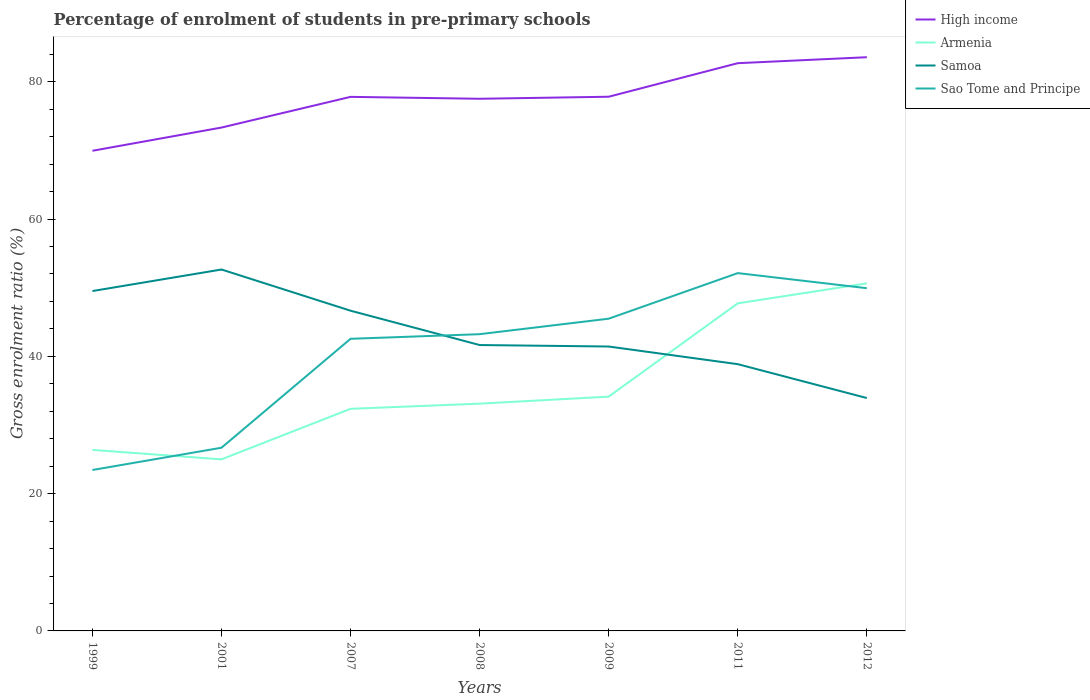Does the line corresponding to High income intersect with the line corresponding to Sao Tome and Principe?
Give a very brief answer. No. Is the number of lines equal to the number of legend labels?
Your answer should be very brief. Yes. Across all years, what is the maximum percentage of students enrolled in pre-primary schools in High income?
Your answer should be compact. 69.94. In which year was the percentage of students enrolled in pre-primary schools in Sao Tome and Principe maximum?
Provide a short and direct response. 1999. What is the total percentage of students enrolled in pre-primary schools in Samoa in the graph?
Provide a succinct answer. 7.79. What is the difference between the highest and the second highest percentage of students enrolled in pre-primary schools in Samoa?
Your answer should be very brief. 18.72. Is the percentage of students enrolled in pre-primary schools in Samoa strictly greater than the percentage of students enrolled in pre-primary schools in Sao Tome and Principe over the years?
Offer a very short reply. No. How many lines are there?
Provide a short and direct response. 4. Are the values on the major ticks of Y-axis written in scientific E-notation?
Make the answer very short. No. Does the graph contain any zero values?
Your answer should be compact. No. Where does the legend appear in the graph?
Your answer should be compact. Top right. What is the title of the graph?
Your answer should be very brief. Percentage of enrolment of students in pre-primary schools. What is the label or title of the X-axis?
Provide a succinct answer. Years. What is the label or title of the Y-axis?
Your answer should be compact. Gross enrolment ratio (%). What is the Gross enrolment ratio (%) in High income in 1999?
Give a very brief answer. 69.94. What is the Gross enrolment ratio (%) in Armenia in 1999?
Your response must be concise. 26.37. What is the Gross enrolment ratio (%) of Samoa in 1999?
Your answer should be compact. 49.51. What is the Gross enrolment ratio (%) of Sao Tome and Principe in 1999?
Offer a terse response. 23.44. What is the Gross enrolment ratio (%) of High income in 2001?
Make the answer very short. 73.33. What is the Gross enrolment ratio (%) in Armenia in 2001?
Provide a succinct answer. 24.99. What is the Gross enrolment ratio (%) in Samoa in 2001?
Give a very brief answer. 52.65. What is the Gross enrolment ratio (%) of Sao Tome and Principe in 2001?
Your answer should be very brief. 26.69. What is the Gross enrolment ratio (%) in High income in 2007?
Offer a very short reply. 77.8. What is the Gross enrolment ratio (%) of Armenia in 2007?
Your answer should be very brief. 32.35. What is the Gross enrolment ratio (%) in Samoa in 2007?
Your answer should be very brief. 46.65. What is the Gross enrolment ratio (%) in Sao Tome and Principe in 2007?
Keep it short and to the point. 42.56. What is the Gross enrolment ratio (%) of High income in 2008?
Ensure brevity in your answer.  77.52. What is the Gross enrolment ratio (%) of Armenia in 2008?
Give a very brief answer. 33.11. What is the Gross enrolment ratio (%) of Samoa in 2008?
Ensure brevity in your answer.  41.65. What is the Gross enrolment ratio (%) of Sao Tome and Principe in 2008?
Your answer should be compact. 43.23. What is the Gross enrolment ratio (%) in High income in 2009?
Keep it short and to the point. 77.82. What is the Gross enrolment ratio (%) of Armenia in 2009?
Keep it short and to the point. 34.13. What is the Gross enrolment ratio (%) of Samoa in 2009?
Your response must be concise. 41.43. What is the Gross enrolment ratio (%) of Sao Tome and Principe in 2009?
Give a very brief answer. 45.48. What is the Gross enrolment ratio (%) of High income in 2011?
Make the answer very short. 82.7. What is the Gross enrolment ratio (%) in Armenia in 2011?
Your response must be concise. 47.72. What is the Gross enrolment ratio (%) of Samoa in 2011?
Your response must be concise. 38.86. What is the Gross enrolment ratio (%) of Sao Tome and Principe in 2011?
Your response must be concise. 52.12. What is the Gross enrolment ratio (%) in High income in 2012?
Your answer should be compact. 83.57. What is the Gross enrolment ratio (%) in Armenia in 2012?
Provide a succinct answer. 50.63. What is the Gross enrolment ratio (%) in Samoa in 2012?
Your response must be concise. 33.92. What is the Gross enrolment ratio (%) in Sao Tome and Principe in 2012?
Your answer should be very brief. 49.93. Across all years, what is the maximum Gross enrolment ratio (%) of High income?
Make the answer very short. 83.57. Across all years, what is the maximum Gross enrolment ratio (%) of Armenia?
Keep it short and to the point. 50.63. Across all years, what is the maximum Gross enrolment ratio (%) in Samoa?
Provide a short and direct response. 52.65. Across all years, what is the maximum Gross enrolment ratio (%) in Sao Tome and Principe?
Give a very brief answer. 52.12. Across all years, what is the minimum Gross enrolment ratio (%) of High income?
Ensure brevity in your answer.  69.94. Across all years, what is the minimum Gross enrolment ratio (%) in Armenia?
Your response must be concise. 24.99. Across all years, what is the minimum Gross enrolment ratio (%) of Samoa?
Keep it short and to the point. 33.92. Across all years, what is the minimum Gross enrolment ratio (%) in Sao Tome and Principe?
Make the answer very short. 23.44. What is the total Gross enrolment ratio (%) of High income in the graph?
Provide a short and direct response. 542.68. What is the total Gross enrolment ratio (%) of Armenia in the graph?
Provide a succinct answer. 249.3. What is the total Gross enrolment ratio (%) of Samoa in the graph?
Offer a terse response. 304.67. What is the total Gross enrolment ratio (%) of Sao Tome and Principe in the graph?
Your answer should be very brief. 283.45. What is the difference between the Gross enrolment ratio (%) of High income in 1999 and that in 2001?
Offer a terse response. -3.38. What is the difference between the Gross enrolment ratio (%) in Armenia in 1999 and that in 2001?
Your answer should be very brief. 1.37. What is the difference between the Gross enrolment ratio (%) of Samoa in 1999 and that in 2001?
Make the answer very short. -3.14. What is the difference between the Gross enrolment ratio (%) of Sao Tome and Principe in 1999 and that in 2001?
Offer a terse response. -3.25. What is the difference between the Gross enrolment ratio (%) in High income in 1999 and that in 2007?
Offer a very short reply. -7.85. What is the difference between the Gross enrolment ratio (%) in Armenia in 1999 and that in 2007?
Keep it short and to the point. -5.99. What is the difference between the Gross enrolment ratio (%) in Samoa in 1999 and that in 2007?
Keep it short and to the point. 2.86. What is the difference between the Gross enrolment ratio (%) of Sao Tome and Principe in 1999 and that in 2007?
Keep it short and to the point. -19.11. What is the difference between the Gross enrolment ratio (%) of High income in 1999 and that in 2008?
Provide a short and direct response. -7.58. What is the difference between the Gross enrolment ratio (%) of Armenia in 1999 and that in 2008?
Offer a very short reply. -6.74. What is the difference between the Gross enrolment ratio (%) in Samoa in 1999 and that in 2008?
Provide a short and direct response. 7.86. What is the difference between the Gross enrolment ratio (%) in Sao Tome and Principe in 1999 and that in 2008?
Provide a succinct answer. -19.78. What is the difference between the Gross enrolment ratio (%) in High income in 1999 and that in 2009?
Make the answer very short. -7.87. What is the difference between the Gross enrolment ratio (%) of Armenia in 1999 and that in 2009?
Offer a very short reply. -7.76. What is the difference between the Gross enrolment ratio (%) in Samoa in 1999 and that in 2009?
Provide a succinct answer. 8.08. What is the difference between the Gross enrolment ratio (%) in Sao Tome and Principe in 1999 and that in 2009?
Provide a succinct answer. -22.04. What is the difference between the Gross enrolment ratio (%) in High income in 1999 and that in 2011?
Make the answer very short. -12.76. What is the difference between the Gross enrolment ratio (%) of Armenia in 1999 and that in 2011?
Your answer should be very brief. -21.35. What is the difference between the Gross enrolment ratio (%) in Samoa in 1999 and that in 2011?
Your answer should be compact. 10.65. What is the difference between the Gross enrolment ratio (%) in Sao Tome and Principe in 1999 and that in 2011?
Your answer should be compact. -28.68. What is the difference between the Gross enrolment ratio (%) in High income in 1999 and that in 2012?
Offer a terse response. -13.63. What is the difference between the Gross enrolment ratio (%) in Armenia in 1999 and that in 2012?
Ensure brevity in your answer.  -24.26. What is the difference between the Gross enrolment ratio (%) in Samoa in 1999 and that in 2012?
Provide a short and direct response. 15.59. What is the difference between the Gross enrolment ratio (%) of Sao Tome and Principe in 1999 and that in 2012?
Make the answer very short. -26.48. What is the difference between the Gross enrolment ratio (%) of High income in 2001 and that in 2007?
Give a very brief answer. -4.47. What is the difference between the Gross enrolment ratio (%) of Armenia in 2001 and that in 2007?
Keep it short and to the point. -7.36. What is the difference between the Gross enrolment ratio (%) in Samoa in 2001 and that in 2007?
Offer a terse response. 6. What is the difference between the Gross enrolment ratio (%) in Sao Tome and Principe in 2001 and that in 2007?
Your answer should be compact. -15.87. What is the difference between the Gross enrolment ratio (%) of High income in 2001 and that in 2008?
Provide a succinct answer. -4.19. What is the difference between the Gross enrolment ratio (%) in Armenia in 2001 and that in 2008?
Ensure brevity in your answer.  -8.12. What is the difference between the Gross enrolment ratio (%) of Samoa in 2001 and that in 2008?
Ensure brevity in your answer.  11. What is the difference between the Gross enrolment ratio (%) of Sao Tome and Principe in 2001 and that in 2008?
Provide a succinct answer. -16.54. What is the difference between the Gross enrolment ratio (%) of High income in 2001 and that in 2009?
Make the answer very short. -4.49. What is the difference between the Gross enrolment ratio (%) of Armenia in 2001 and that in 2009?
Offer a very short reply. -9.14. What is the difference between the Gross enrolment ratio (%) in Samoa in 2001 and that in 2009?
Ensure brevity in your answer.  11.22. What is the difference between the Gross enrolment ratio (%) in Sao Tome and Principe in 2001 and that in 2009?
Give a very brief answer. -18.79. What is the difference between the Gross enrolment ratio (%) of High income in 2001 and that in 2011?
Your response must be concise. -9.38. What is the difference between the Gross enrolment ratio (%) in Armenia in 2001 and that in 2011?
Your response must be concise. -22.73. What is the difference between the Gross enrolment ratio (%) of Samoa in 2001 and that in 2011?
Make the answer very short. 13.79. What is the difference between the Gross enrolment ratio (%) in Sao Tome and Principe in 2001 and that in 2011?
Your response must be concise. -25.44. What is the difference between the Gross enrolment ratio (%) in High income in 2001 and that in 2012?
Offer a very short reply. -10.25. What is the difference between the Gross enrolment ratio (%) of Armenia in 2001 and that in 2012?
Give a very brief answer. -25.64. What is the difference between the Gross enrolment ratio (%) in Samoa in 2001 and that in 2012?
Give a very brief answer. 18.72. What is the difference between the Gross enrolment ratio (%) of Sao Tome and Principe in 2001 and that in 2012?
Provide a short and direct response. -23.24. What is the difference between the Gross enrolment ratio (%) in High income in 2007 and that in 2008?
Give a very brief answer. 0.28. What is the difference between the Gross enrolment ratio (%) of Armenia in 2007 and that in 2008?
Make the answer very short. -0.75. What is the difference between the Gross enrolment ratio (%) in Samoa in 2007 and that in 2008?
Keep it short and to the point. 5. What is the difference between the Gross enrolment ratio (%) in Sao Tome and Principe in 2007 and that in 2008?
Give a very brief answer. -0.67. What is the difference between the Gross enrolment ratio (%) of High income in 2007 and that in 2009?
Ensure brevity in your answer.  -0.02. What is the difference between the Gross enrolment ratio (%) of Armenia in 2007 and that in 2009?
Offer a very short reply. -1.77. What is the difference between the Gross enrolment ratio (%) in Samoa in 2007 and that in 2009?
Your answer should be very brief. 5.22. What is the difference between the Gross enrolment ratio (%) of Sao Tome and Principe in 2007 and that in 2009?
Provide a succinct answer. -2.93. What is the difference between the Gross enrolment ratio (%) of High income in 2007 and that in 2011?
Give a very brief answer. -4.91. What is the difference between the Gross enrolment ratio (%) in Armenia in 2007 and that in 2011?
Make the answer very short. -15.37. What is the difference between the Gross enrolment ratio (%) in Samoa in 2007 and that in 2011?
Give a very brief answer. 7.79. What is the difference between the Gross enrolment ratio (%) in Sao Tome and Principe in 2007 and that in 2011?
Provide a succinct answer. -9.57. What is the difference between the Gross enrolment ratio (%) in High income in 2007 and that in 2012?
Give a very brief answer. -5.77. What is the difference between the Gross enrolment ratio (%) of Armenia in 2007 and that in 2012?
Your answer should be very brief. -18.28. What is the difference between the Gross enrolment ratio (%) of Samoa in 2007 and that in 2012?
Ensure brevity in your answer.  12.72. What is the difference between the Gross enrolment ratio (%) of Sao Tome and Principe in 2007 and that in 2012?
Ensure brevity in your answer.  -7.37. What is the difference between the Gross enrolment ratio (%) in High income in 2008 and that in 2009?
Offer a terse response. -0.3. What is the difference between the Gross enrolment ratio (%) of Armenia in 2008 and that in 2009?
Your answer should be compact. -1.02. What is the difference between the Gross enrolment ratio (%) in Samoa in 2008 and that in 2009?
Provide a succinct answer. 0.22. What is the difference between the Gross enrolment ratio (%) of Sao Tome and Principe in 2008 and that in 2009?
Make the answer very short. -2.26. What is the difference between the Gross enrolment ratio (%) of High income in 2008 and that in 2011?
Give a very brief answer. -5.18. What is the difference between the Gross enrolment ratio (%) in Armenia in 2008 and that in 2011?
Your response must be concise. -14.61. What is the difference between the Gross enrolment ratio (%) of Samoa in 2008 and that in 2011?
Give a very brief answer. 2.79. What is the difference between the Gross enrolment ratio (%) in Sao Tome and Principe in 2008 and that in 2011?
Ensure brevity in your answer.  -8.9. What is the difference between the Gross enrolment ratio (%) in High income in 2008 and that in 2012?
Provide a succinct answer. -6.05. What is the difference between the Gross enrolment ratio (%) of Armenia in 2008 and that in 2012?
Offer a very short reply. -17.52. What is the difference between the Gross enrolment ratio (%) in Samoa in 2008 and that in 2012?
Provide a short and direct response. 7.72. What is the difference between the Gross enrolment ratio (%) of Sao Tome and Principe in 2008 and that in 2012?
Provide a short and direct response. -6.7. What is the difference between the Gross enrolment ratio (%) in High income in 2009 and that in 2011?
Offer a terse response. -4.89. What is the difference between the Gross enrolment ratio (%) in Armenia in 2009 and that in 2011?
Your answer should be compact. -13.59. What is the difference between the Gross enrolment ratio (%) in Samoa in 2009 and that in 2011?
Ensure brevity in your answer.  2.57. What is the difference between the Gross enrolment ratio (%) in Sao Tome and Principe in 2009 and that in 2011?
Provide a short and direct response. -6.64. What is the difference between the Gross enrolment ratio (%) of High income in 2009 and that in 2012?
Offer a very short reply. -5.76. What is the difference between the Gross enrolment ratio (%) of Armenia in 2009 and that in 2012?
Provide a short and direct response. -16.5. What is the difference between the Gross enrolment ratio (%) in Samoa in 2009 and that in 2012?
Provide a short and direct response. 7.5. What is the difference between the Gross enrolment ratio (%) of Sao Tome and Principe in 2009 and that in 2012?
Keep it short and to the point. -4.44. What is the difference between the Gross enrolment ratio (%) of High income in 2011 and that in 2012?
Keep it short and to the point. -0.87. What is the difference between the Gross enrolment ratio (%) in Armenia in 2011 and that in 2012?
Keep it short and to the point. -2.91. What is the difference between the Gross enrolment ratio (%) in Samoa in 2011 and that in 2012?
Give a very brief answer. 4.93. What is the difference between the Gross enrolment ratio (%) of Sao Tome and Principe in 2011 and that in 2012?
Give a very brief answer. 2.2. What is the difference between the Gross enrolment ratio (%) in High income in 1999 and the Gross enrolment ratio (%) in Armenia in 2001?
Provide a short and direct response. 44.95. What is the difference between the Gross enrolment ratio (%) of High income in 1999 and the Gross enrolment ratio (%) of Samoa in 2001?
Offer a terse response. 17.3. What is the difference between the Gross enrolment ratio (%) of High income in 1999 and the Gross enrolment ratio (%) of Sao Tome and Principe in 2001?
Offer a very short reply. 43.26. What is the difference between the Gross enrolment ratio (%) of Armenia in 1999 and the Gross enrolment ratio (%) of Samoa in 2001?
Your answer should be compact. -26.28. What is the difference between the Gross enrolment ratio (%) in Armenia in 1999 and the Gross enrolment ratio (%) in Sao Tome and Principe in 2001?
Your answer should be very brief. -0.32. What is the difference between the Gross enrolment ratio (%) of Samoa in 1999 and the Gross enrolment ratio (%) of Sao Tome and Principe in 2001?
Your response must be concise. 22.82. What is the difference between the Gross enrolment ratio (%) of High income in 1999 and the Gross enrolment ratio (%) of Armenia in 2007?
Offer a terse response. 37.59. What is the difference between the Gross enrolment ratio (%) of High income in 1999 and the Gross enrolment ratio (%) of Samoa in 2007?
Your answer should be compact. 23.3. What is the difference between the Gross enrolment ratio (%) in High income in 1999 and the Gross enrolment ratio (%) in Sao Tome and Principe in 2007?
Make the answer very short. 27.39. What is the difference between the Gross enrolment ratio (%) of Armenia in 1999 and the Gross enrolment ratio (%) of Samoa in 2007?
Provide a short and direct response. -20.28. What is the difference between the Gross enrolment ratio (%) of Armenia in 1999 and the Gross enrolment ratio (%) of Sao Tome and Principe in 2007?
Offer a terse response. -16.19. What is the difference between the Gross enrolment ratio (%) of Samoa in 1999 and the Gross enrolment ratio (%) of Sao Tome and Principe in 2007?
Offer a terse response. 6.96. What is the difference between the Gross enrolment ratio (%) of High income in 1999 and the Gross enrolment ratio (%) of Armenia in 2008?
Provide a short and direct response. 36.84. What is the difference between the Gross enrolment ratio (%) of High income in 1999 and the Gross enrolment ratio (%) of Samoa in 2008?
Make the answer very short. 28.3. What is the difference between the Gross enrolment ratio (%) in High income in 1999 and the Gross enrolment ratio (%) in Sao Tome and Principe in 2008?
Keep it short and to the point. 26.72. What is the difference between the Gross enrolment ratio (%) in Armenia in 1999 and the Gross enrolment ratio (%) in Samoa in 2008?
Offer a very short reply. -15.28. What is the difference between the Gross enrolment ratio (%) of Armenia in 1999 and the Gross enrolment ratio (%) of Sao Tome and Principe in 2008?
Offer a very short reply. -16.86. What is the difference between the Gross enrolment ratio (%) in Samoa in 1999 and the Gross enrolment ratio (%) in Sao Tome and Principe in 2008?
Give a very brief answer. 6.28. What is the difference between the Gross enrolment ratio (%) of High income in 1999 and the Gross enrolment ratio (%) of Armenia in 2009?
Make the answer very short. 35.82. What is the difference between the Gross enrolment ratio (%) of High income in 1999 and the Gross enrolment ratio (%) of Samoa in 2009?
Offer a terse response. 28.51. What is the difference between the Gross enrolment ratio (%) of High income in 1999 and the Gross enrolment ratio (%) of Sao Tome and Principe in 2009?
Provide a short and direct response. 24.46. What is the difference between the Gross enrolment ratio (%) in Armenia in 1999 and the Gross enrolment ratio (%) in Samoa in 2009?
Keep it short and to the point. -15.06. What is the difference between the Gross enrolment ratio (%) of Armenia in 1999 and the Gross enrolment ratio (%) of Sao Tome and Principe in 2009?
Your response must be concise. -19.12. What is the difference between the Gross enrolment ratio (%) of Samoa in 1999 and the Gross enrolment ratio (%) of Sao Tome and Principe in 2009?
Offer a very short reply. 4.03. What is the difference between the Gross enrolment ratio (%) in High income in 1999 and the Gross enrolment ratio (%) in Armenia in 2011?
Give a very brief answer. 22.22. What is the difference between the Gross enrolment ratio (%) of High income in 1999 and the Gross enrolment ratio (%) of Samoa in 2011?
Your answer should be very brief. 31.08. What is the difference between the Gross enrolment ratio (%) in High income in 1999 and the Gross enrolment ratio (%) in Sao Tome and Principe in 2011?
Offer a very short reply. 17.82. What is the difference between the Gross enrolment ratio (%) of Armenia in 1999 and the Gross enrolment ratio (%) of Samoa in 2011?
Your answer should be compact. -12.49. What is the difference between the Gross enrolment ratio (%) of Armenia in 1999 and the Gross enrolment ratio (%) of Sao Tome and Principe in 2011?
Offer a very short reply. -25.76. What is the difference between the Gross enrolment ratio (%) of Samoa in 1999 and the Gross enrolment ratio (%) of Sao Tome and Principe in 2011?
Offer a terse response. -2.61. What is the difference between the Gross enrolment ratio (%) of High income in 1999 and the Gross enrolment ratio (%) of Armenia in 2012?
Your answer should be very brief. 19.31. What is the difference between the Gross enrolment ratio (%) of High income in 1999 and the Gross enrolment ratio (%) of Samoa in 2012?
Your answer should be compact. 36.02. What is the difference between the Gross enrolment ratio (%) of High income in 1999 and the Gross enrolment ratio (%) of Sao Tome and Principe in 2012?
Your response must be concise. 20.02. What is the difference between the Gross enrolment ratio (%) of Armenia in 1999 and the Gross enrolment ratio (%) of Samoa in 2012?
Your answer should be compact. -7.56. What is the difference between the Gross enrolment ratio (%) in Armenia in 1999 and the Gross enrolment ratio (%) in Sao Tome and Principe in 2012?
Your answer should be compact. -23.56. What is the difference between the Gross enrolment ratio (%) of Samoa in 1999 and the Gross enrolment ratio (%) of Sao Tome and Principe in 2012?
Your answer should be very brief. -0.42. What is the difference between the Gross enrolment ratio (%) of High income in 2001 and the Gross enrolment ratio (%) of Armenia in 2007?
Your response must be concise. 40.97. What is the difference between the Gross enrolment ratio (%) in High income in 2001 and the Gross enrolment ratio (%) in Samoa in 2007?
Ensure brevity in your answer.  26.68. What is the difference between the Gross enrolment ratio (%) in High income in 2001 and the Gross enrolment ratio (%) in Sao Tome and Principe in 2007?
Offer a very short reply. 30.77. What is the difference between the Gross enrolment ratio (%) of Armenia in 2001 and the Gross enrolment ratio (%) of Samoa in 2007?
Offer a very short reply. -21.66. What is the difference between the Gross enrolment ratio (%) in Armenia in 2001 and the Gross enrolment ratio (%) in Sao Tome and Principe in 2007?
Offer a terse response. -17.56. What is the difference between the Gross enrolment ratio (%) in Samoa in 2001 and the Gross enrolment ratio (%) in Sao Tome and Principe in 2007?
Make the answer very short. 10.09. What is the difference between the Gross enrolment ratio (%) in High income in 2001 and the Gross enrolment ratio (%) in Armenia in 2008?
Your response must be concise. 40.22. What is the difference between the Gross enrolment ratio (%) of High income in 2001 and the Gross enrolment ratio (%) of Samoa in 2008?
Your answer should be very brief. 31.68. What is the difference between the Gross enrolment ratio (%) of High income in 2001 and the Gross enrolment ratio (%) of Sao Tome and Principe in 2008?
Your answer should be compact. 30.1. What is the difference between the Gross enrolment ratio (%) of Armenia in 2001 and the Gross enrolment ratio (%) of Samoa in 2008?
Provide a short and direct response. -16.65. What is the difference between the Gross enrolment ratio (%) in Armenia in 2001 and the Gross enrolment ratio (%) in Sao Tome and Principe in 2008?
Ensure brevity in your answer.  -18.23. What is the difference between the Gross enrolment ratio (%) in Samoa in 2001 and the Gross enrolment ratio (%) in Sao Tome and Principe in 2008?
Provide a succinct answer. 9.42. What is the difference between the Gross enrolment ratio (%) of High income in 2001 and the Gross enrolment ratio (%) of Armenia in 2009?
Offer a very short reply. 39.2. What is the difference between the Gross enrolment ratio (%) in High income in 2001 and the Gross enrolment ratio (%) in Samoa in 2009?
Your answer should be very brief. 31.9. What is the difference between the Gross enrolment ratio (%) in High income in 2001 and the Gross enrolment ratio (%) in Sao Tome and Principe in 2009?
Provide a succinct answer. 27.84. What is the difference between the Gross enrolment ratio (%) of Armenia in 2001 and the Gross enrolment ratio (%) of Samoa in 2009?
Offer a terse response. -16.44. What is the difference between the Gross enrolment ratio (%) of Armenia in 2001 and the Gross enrolment ratio (%) of Sao Tome and Principe in 2009?
Keep it short and to the point. -20.49. What is the difference between the Gross enrolment ratio (%) in Samoa in 2001 and the Gross enrolment ratio (%) in Sao Tome and Principe in 2009?
Provide a short and direct response. 7.17. What is the difference between the Gross enrolment ratio (%) in High income in 2001 and the Gross enrolment ratio (%) in Armenia in 2011?
Make the answer very short. 25.61. What is the difference between the Gross enrolment ratio (%) in High income in 2001 and the Gross enrolment ratio (%) in Samoa in 2011?
Your answer should be compact. 34.47. What is the difference between the Gross enrolment ratio (%) of High income in 2001 and the Gross enrolment ratio (%) of Sao Tome and Principe in 2011?
Give a very brief answer. 21.2. What is the difference between the Gross enrolment ratio (%) in Armenia in 2001 and the Gross enrolment ratio (%) in Samoa in 2011?
Keep it short and to the point. -13.87. What is the difference between the Gross enrolment ratio (%) of Armenia in 2001 and the Gross enrolment ratio (%) of Sao Tome and Principe in 2011?
Your response must be concise. -27.13. What is the difference between the Gross enrolment ratio (%) of Samoa in 2001 and the Gross enrolment ratio (%) of Sao Tome and Principe in 2011?
Ensure brevity in your answer.  0.52. What is the difference between the Gross enrolment ratio (%) of High income in 2001 and the Gross enrolment ratio (%) of Armenia in 2012?
Your answer should be very brief. 22.7. What is the difference between the Gross enrolment ratio (%) in High income in 2001 and the Gross enrolment ratio (%) in Samoa in 2012?
Your answer should be compact. 39.4. What is the difference between the Gross enrolment ratio (%) in High income in 2001 and the Gross enrolment ratio (%) in Sao Tome and Principe in 2012?
Keep it short and to the point. 23.4. What is the difference between the Gross enrolment ratio (%) in Armenia in 2001 and the Gross enrolment ratio (%) in Samoa in 2012?
Your answer should be compact. -8.93. What is the difference between the Gross enrolment ratio (%) in Armenia in 2001 and the Gross enrolment ratio (%) in Sao Tome and Principe in 2012?
Ensure brevity in your answer.  -24.93. What is the difference between the Gross enrolment ratio (%) in Samoa in 2001 and the Gross enrolment ratio (%) in Sao Tome and Principe in 2012?
Keep it short and to the point. 2.72. What is the difference between the Gross enrolment ratio (%) in High income in 2007 and the Gross enrolment ratio (%) in Armenia in 2008?
Offer a very short reply. 44.69. What is the difference between the Gross enrolment ratio (%) in High income in 2007 and the Gross enrolment ratio (%) in Samoa in 2008?
Give a very brief answer. 36.15. What is the difference between the Gross enrolment ratio (%) of High income in 2007 and the Gross enrolment ratio (%) of Sao Tome and Principe in 2008?
Keep it short and to the point. 34.57. What is the difference between the Gross enrolment ratio (%) of Armenia in 2007 and the Gross enrolment ratio (%) of Samoa in 2008?
Offer a terse response. -9.29. What is the difference between the Gross enrolment ratio (%) in Armenia in 2007 and the Gross enrolment ratio (%) in Sao Tome and Principe in 2008?
Your answer should be compact. -10.87. What is the difference between the Gross enrolment ratio (%) in Samoa in 2007 and the Gross enrolment ratio (%) in Sao Tome and Principe in 2008?
Give a very brief answer. 3.42. What is the difference between the Gross enrolment ratio (%) of High income in 2007 and the Gross enrolment ratio (%) of Armenia in 2009?
Make the answer very short. 43.67. What is the difference between the Gross enrolment ratio (%) of High income in 2007 and the Gross enrolment ratio (%) of Samoa in 2009?
Your answer should be compact. 36.37. What is the difference between the Gross enrolment ratio (%) in High income in 2007 and the Gross enrolment ratio (%) in Sao Tome and Principe in 2009?
Your answer should be compact. 32.32. What is the difference between the Gross enrolment ratio (%) in Armenia in 2007 and the Gross enrolment ratio (%) in Samoa in 2009?
Make the answer very short. -9.08. What is the difference between the Gross enrolment ratio (%) in Armenia in 2007 and the Gross enrolment ratio (%) in Sao Tome and Principe in 2009?
Your answer should be very brief. -13.13. What is the difference between the Gross enrolment ratio (%) of Samoa in 2007 and the Gross enrolment ratio (%) of Sao Tome and Principe in 2009?
Your answer should be compact. 1.17. What is the difference between the Gross enrolment ratio (%) in High income in 2007 and the Gross enrolment ratio (%) in Armenia in 2011?
Make the answer very short. 30.08. What is the difference between the Gross enrolment ratio (%) of High income in 2007 and the Gross enrolment ratio (%) of Samoa in 2011?
Offer a terse response. 38.94. What is the difference between the Gross enrolment ratio (%) in High income in 2007 and the Gross enrolment ratio (%) in Sao Tome and Principe in 2011?
Offer a very short reply. 25.67. What is the difference between the Gross enrolment ratio (%) of Armenia in 2007 and the Gross enrolment ratio (%) of Samoa in 2011?
Offer a very short reply. -6.5. What is the difference between the Gross enrolment ratio (%) in Armenia in 2007 and the Gross enrolment ratio (%) in Sao Tome and Principe in 2011?
Provide a short and direct response. -19.77. What is the difference between the Gross enrolment ratio (%) in Samoa in 2007 and the Gross enrolment ratio (%) in Sao Tome and Principe in 2011?
Offer a terse response. -5.48. What is the difference between the Gross enrolment ratio (%) of High income in 2007 and the Gross enrolment ratio (%) of Armenia in 2012?
Your response must be concise. 27.17. What is the difference between the Gross enrolment ratio (%) of High income in 2007 and the Gross enrolment ratio (%) of Samoa in 2012?
Ensure brevity in your answer.  43.87. What is the difference between the Gross enrolment ratio (%) of High income in 2007 and the Gross enrolment ratio (%) of Sao Tome and Principe in 2012?
Offer a terse response. 27.87. What is the difference between the Gross enrolment ratio (%) in Armenia in 2007 and the Gross enrolment ratio (%) in Samoa in 2012?
Your response must be concise. -1.57. What is the difference between the Gross enrolment ratio (%) in Armenia in 2007 and the Gross enrolment ratio (%) in Sao Tome and Principe in 2012?
Ensure brevity in your answer.  -17.57. What is the difference between the Gross enrolment ratio (%) in Samoa in 2007 and the Gross enrolment ratio (%) in Sao Tome and Principe in 2012?
Provide a succinct answer. -3.28. What is the difference between the Gross enrolment ratio (%) in High income in 2008 and the Gross enrolment ratio (%) in Armenia in 2009?
Ensure brevity in your answer.  43.39. What is the difference between the Gross enrolment ratio (%) in High income in 2008 and the Gross enrolment ratio (%) in Samoa in 2009?
Ensure brevity in your answer.  36.09. What is the difference between the Gross enrolment ratio (%) in High income in 2008 and the Gross enrolment ratio (%) in Sao Tome and Principe in 2009?
Your response must be concise. 32.04. What is the difference between the Gross enrolment ratio (%) in Armenia in 2008 and the Gross enrolment ratio (%) in Samoa in 2009?
Provide a short and direct response. -8.32. What is the difference between the Gross enrolment ratio (%) in Armenia in 2008 and the Gross enrolment ratio (%) in Sao Tome and Principe in 2009?
Provide a succinct answer. -12.37. What is the difference between the Gross enrolment ratio (%) in Samoa in 2008 and the Gross enrolment ratio (%) in Sao Tome and Principe in 2009?
Your answer should be very brief. -3.83. What is the difference between the Gross enrolment ratio (%) in High income in 2008 and the Gross enrolment ratio (%) in Armenia in 2011?
Provide a short and direct response. 29.8. What is the difference between the Gross enrolment ratio (%) of High income in 2008 and the Gross enrolment ratio (%) of Samoa in 2011?
Offer a terse response. 38.66. What is the difference between the Gross enrolment ratio (%) in High income in 2008 and the Gross enrolment ratio (%) in Sao Tome and Principe in 2011?
Offer a very short reply. 25.4. What is the difference between the Gross enrolment ratio (%) in Armenia in 2008 and the Gross enrolment ratio (%) in Samoa in 2011?
Keep it short and to the point. -5.75. What is the difference between the Gross enrolment ratio (%) in Armenia in 2008 and the Gross enrolment ratio (%) in Sao Tome and Principe in 2011?
Offer a terse response. -19.02. What is the difference between the Gross enrolment ratio (%) of Samoa in 2008 and the Gross enrolment ratio (%) of Sao Tome and Principe in 2011?
Offer a very short reply. -10.48. What is the difference between the Gross enrolment ratio (%) of High income in 2008 and the Gross enrolment ratio (%) of Armenia in 2012?
Offer a very short reply. 26.89. What is the difference between the Gross enrolment ratio (%) of High income in 2008 and the Gross enrolment ratio (%) of Samoa in 2012?
Provide a short and direct response. 43.59. What is the difference between the Gross enrolment ratio (%) of High income in 2008 and the Gross enrolment ratio (%) of Sao Tome and Principe in 2012?
Provide a succinct answer. 27.59. What is the difference between the Gross enrolment ratio (%) in Armenia in 2008 and the Gross enrolment ratio (%) in Samoa in 2012?
Offer a very short reply. -0.82. What is the difference between the Gross enrolment ratio (%) in Armenia in 2008 and the Gross enrolment ratio (%) in Sao Tome and Principe in 2012?
Keep it short and to the point. -16.82. What is the difference between the Gross enrolment ratio (%) in Samoa in 2008 and the Gross enrolment ratio (%) in Sao Tome and Principe in 2012?
Ensure brevity in your answer.  -8.28. What is the difference between the Gross enrolment ratio (%) in High income in 2009 and the Gross enrolment ratio (%) in Armenia in 2011?
Keep it short and to the point. 30.1. What is the difference between the Gross enrolment ratio (%) in High income in 2009 and the Gross enrolment ratio (%) in Samoa in 2011?
Your response must be concise. 38.96. What is the difference between the Gross enrolment ratio (%) of High income in 2009 and the Gross enrolment ratio (%) of Sao Tome and Principe in 2011?
Offer a terse response. 25.69. What is the difference between the Gross enrolment ratio (%) of Armenia in 2009 and the Gross enrolment ratio (%) of Samoa in 2011?
Offer a terse response. -4.73. What is the difference between the Gross enrolment ratio (%) in Armenia in 2009 and the Gross enrolment ratio (%) in Sao Tome and Principe in 2011?
Ensure brevity in your answer.  -17.99. What is the difference between the Gross enrolment ratio (%) in Samoa in 2009 and the Gross enrolment ratio (%) in Sao Tome and Principe in 2011?
Give a very brief answer. -10.69. What is the difference between the Gross enrolment ratio (%) of High income in 2009 and the Gross enrolment ratio (%) of Armenia in 2012?
Your answer should be compact. 27.19. What is the difference between the Gross enrolment ratio (%) in High income in 2009 and the Gross enrolment ratio (%) in Samoa in 2012?
Your answer should be very brief. 43.89. What is the difference between the Gross enrolment ratio (%) in High income in 2009 and the Gross enrolment ratio (%) in Sao Tome and Principe in 2012?
Provide a succinct answer. 27.89. What is the difference between the Gross enrolment ratio (%) in Armenia in 2009 and the Gross enrolment ratio (%) in Samoa in 2012?
Offer a terse response. 0.2. What is the difference between the Gross enrolment ratio (%) in Armenia in 2009 and the Gross enrolment ratio (%) in Sao Tome and Principe in 2012?
Make the answer very short. -15.8. What is the difference between the Gross enrolment ratio (%) in Samoa in 2009 and the Gross enrolment ratio (%) in Sao Tome and Principe in 2012?
Ensure brevity in your answer.  -8.5. What is the difference between the Gross enrolment ratio (%) of High income in 2011 and the Gross enrolment ratio (%) of Armenia in 2012?
Provide a succinct answer. 32.07. What is the difference between the Gross enrolment ratio (%) in High income in 2011 and the Gross enrolment ratio (%) in Samoa in 2012?
Your response must be concise. 48.78. What is the difference between the Gross enrolment ratio (%) of High income in 2011 and the Gross enrolment ratio (%) of Sao Tome and Principe in 2012?
Your answer should be compact. 32.78. What is the difference between the Gross enrolment ratio (%) in Armenia in 2011 and the Gross enrolment ratio (%) in Samoa in 2012?
Your answer should be very brief. 13.79. What is the difference between the Gross enrolment ratio (%) of Armenia in 2011 and the Gross enrolment ratio (%) of Sao Tome and Principe in 2012?
Your response must be concise. -2.21. What is the difference between the Gross enrolment ratio (%) in Samoa in 2011 and the Gross enrolment ratio (%) in Sao Tome and Principe in 2012?
Make the answer very short. -11.07. What is the average Gross enrolment ratio (%) of High income per year?
Provide a succinct answer. 77.53. What is the average Gross enrolment ratio (%) of Armenia per year?
Offer a terse response. 35.61. What is the average Gross enrolment ratio (%) of Samoa per year?
Offer a very short reply. 43.52. What is the average Gross enrolment ratio (%) of Sao Tome and Principe per year?
Provide a succinct answer. 40.49. In the year 1999, what is the difference between the Gross enrolment ratio (%) in High income and Gross enrolment ratio (%) in Armenia?
Provide a succinct answer. 43.58. In the year 1999, what is the difference between the Gross enrolment ratio (%) in High income and Gross enrolment ratio (%) in Samoa?
Ensure brevity in your answer.  20.43. In the year 1999, what is the difference between the Gross enrolment ratio (%) in High income and Gross enrolment ratio (%) in Sao Tome and Principe?
Provide a short and direct response. 46.5. In the year 1999, what is the difference between the Gross enrolment ratio (%) of Armenia and Gross enrolment ratio (%) of Samoa?
Your answer should be compact. -23.14. In the year 1999, what is the difference between the Gross enrolment ratio (%) in Armenia and Gross enrolment ratio (%) in Sao Tome and Principe?
Keep it short and to the point. 2.92. In the year 1999, what is the difference between the Gross enrolment ratio (%) in Samoa and Gross enrolment ratio (%) in Sao Tome and Principe?
Offer a terse response. 26.07. In the year 2001, what is the difference between the Gross enrolment ratio (%) of High income and Gross enrolment ratio (%) of Armenia?
Provide a short and direct response. 48.33. In the year 2001, what is the difference between the Gross enrolment ratio (%) in High income and Gross enrolment ratio (%) in Samoa?
Offer a very short reply. 20.68. In the year 2001, what is the difference between the Gross enrolment ratio (%) of High income and Gross enrolment ratio (%) of Sao Tome and Principe?
Provide a succinct answer. 46.64. In the year 2001, what is the difference between the Gross enrolment ratio (%) of Armenia and Gross enrolment ratio (%) of Samoa?
Your answer should be very brief. -27.66. In the year 2001, what is the difference between the Gross enrolment ratio (%) of Armenia and Gross enrolment ratio (%) of Sao Tome and Principe?
Keep it short and to the point. -1.7. In the year 2001, what is the difference between the Gross enrolment ratio (%) in Samoa and Gross enrolment ratio (%) in Sao Tome and Principe?
Offer a very short reply. 25.96. In the year 2007, what is the difference between the Gross enrolment ratio (%) of High income and Gross enrolment ratio (%) of Armenia?
Provide a short and direct response. 45.44. In the year 2007, what is the difference between the Gross enrolment ratio (%) in High income and Gross enrolment ratio (%) in Samoa?
Provide a succinct answer. 31.15. In the year 2007, what is the difference between the Gross enrolment ratio (%) of High income and Gross enrolment ratio (%) of Sao Tome and Principe?
Offer a very short reply. 35.24. In the year 2007, what is the difference between the Gross enrolment ratio (%) in Armenia and Gross enrolment ratio (%) in Samoa?
Keep it short and to the point. -14.29. In the year 2007, what is the difference between the Gross enrolment ratio (%) in Armenia and Gross enrolment ratio (%) in Sao Tome and Principe?
Ensure brevity in your answer.  -10.2. In the year 2007, what is the difference between the Gross enrolment ratio (%) in Samoa and Gross enrolment ratio (%) in Sao Tome and Principe?
Provide a short and direct response. 4.09. In the year 2008, what is the difference between the Gross enrolment ratio (%) of High income and Gross enrolment ratio (%) of Armenia?
Provide a short and direct response. 44.41. In the year 2008, what is the difference between the Gross enrolment ratio (%) of High income and Gross enrolment ratio (%) of Samoa?
Offer a terse response. 35.87. In the year 2008, what is the difference between the Gross enrolment ratio (%) of High income and Gross enrolment ratio (%) of Sao Tome and Principe?
Provide a short and direct response. 34.29. In the year 2008, what is the difference between the Gross enrolment ratio (%) in Armenia and Gross enrolment ratio (%) in Samoa?
Your response must be concise. -8.54. In the year 2008, what is the difference between the Gross enrolment ratio (%) of Armenia and Gross enrolment ratio (%) of Sao Tome and Principe?
Provide a short and direct response. -10.12. In the year 2008, what is the difference between the Gross enrolment ratio (%) of Samoa and Gross enrolment ratio (%) of Sao Tome and Principe?
Your response must be concise. -1.58. In the year 2009, what is the difference between the Gross enrolment ratio (%) in High income and Gross enrolment ratio (%) in Armenia?
Offer a very short reply. 43.69. In the year 2009, what is the difference between the Gross enrolment ratio (%) in High income and Gross enrolment ratio (%) in Samoa?
Give a very brief answer. 36.39. In the year 2009, what is the difference between the Gross enrolment ratio (%) of High income and Gross enrolment ratio (%) of Sao Tome and Principe?
Give a very brief answer. 32.33. In the year 2009, what is the difference between the Gross enrolment ratio (%) of Armenia and Gross enrolment ratio (%) of Samoa?
Give a very brief answer. -7.3. In the year 2009, what is the difference between the Gross enrolment ratio (%) in Armenia and Gross enrolment ratio (%) in Sao Tome and Principe?
Ensure brevity in your answer.  -11.35. In the year 2009, what is the difference between the Gross enrolment ratio (%) in Samoa and Gross enrolment ratio (%) in Sao Tome and Principe?
Your answer should be compact. -4.05. In the year 2011, what is the difference between the Gross enrolment ratio (%) of High income and Gross enrolment ratio (%) of Armenia?
Provide a short and direct response. 34.98. In the year 2011, what is the difference between the Gross enrolment ratio (%) of High income and Gross enrolment ratio (%) of Samoa?
Ensure brevity in your answer.  43.84. In the year 2011, what is the difference between the Gross enrolment ratio (%) of High income and Gross enrolment ratio (%) of Sao Tome and Principe?
Keep it short and to the point. 30.58. In the year 2011, what is the difference between the Gross enrolment ratio (%) in Armenia and Gross enrolment ratio (%) in Samoa?
Your response must be concise. 8.86. In the year 2011, what is the difference between the Gross enrolment ratio (%) in Armenia and Gross enrolment ratio (%) in Sao Tome and Principe?
Ensure brevity in your answer.  -4.4. In the year 2011, what is the difference between the Gross enrolment ratio (%) of Samoa and Gross enrolment ratio (%) of Sao Tome and Principe?
Offer a very short reply. -13.26. In the year 2012, what is the difference between the Gross enrolment ratio (%) in High income and Gross enrolment ratio (%) in Armenia?
Give a very brief answer. 32.94. In the year 2012, what is the difference between the Gross enrolment ratio (%) in High income and Gross enrolment ratio (%) in Samoa?
Provide a short and direct response. 49.65. In the year 2012, what is the difference between the Gross enrolment ratio (%) of High income and Gross enrolment ratio (%) of Sao Tome and Principe?
Provide a succinct answer. 33.65. In the year 2012, what is the difference between the Gross enrolment ratio (%) in Armenia and Gross enrolment ratio (%) in Samoa?
Your response must be concise. 16.71. In the year 2012, what is the difference between the Gross enrolment ratio (%) in Armenia and Gross enrolment ratio (%) in Sao Tome and Principe?
Your response must be concise. 0.7. In the year 2012, what is the difference between the Gross enrolment ratio (%) of Samoa and Gross enrolment ratio (%) of Sao Tome and Principe?
Provide a succinct answer. -16. What is the ratio of the Gross enrolment ratio (%) of High income in 1999 to that in 2001?
Give a very brief answer. 0.95. What is the ratio of the Gross enrolment ratio (%) of Armenia in 1999 to that in 2001?
Your response must be concise. 1.05. What is the ratio of the Gross enrolment ratio (%) in Samoa in 1999 to that in 2001?
Your answer should be very brief. 0.94. What is the ratio of the Gross enrolment ratio (%) in Sao Tome and Principe in 1999 to that in 2001?
Provide a short and direct response. 0.88. What is the ratio of the Gross enrolment ratio (%) in High income in 1999 to that in 2007?
Your answer should be very brief. 0.9. What is the ratio of the Gross enrolment ratio (%) of Armenia in 1999 to that in 2007?
Your response must be concise. 0.81. What is the ratio of the Gross enrolment ratio (%) in Samoa in 1999 to that in 2007?
Your answer should be very brief. 1.06. What is the ratio of the Gross enrolment ratio (%) of Sao Tome and Principe in 1999 to that in 2007?
Your answer should be very brief. 0.55. What is the ratio of the Gross enrolment ratio (%) of High income in 1999 to that in 2008?
Offer a terse response. 0.9. What is the ratio of the Gross enrolment ratio (%) in Armenia in 1999 to that in 2008?
Your response must be concise. 0.8. What is the ratio of the Gross enrolment ratio (%) in Samoa in 1999 to that in 2008?
Your answer should be compact. 1.19. What is the ratio of the Gross enrolment ratio (%) of Sao Tome and Principe in 1999 to that in 2008?
Keep it short and to the point. 0.54. What is the ratio of the Gross enrolment ratio (%) in High income in 1999 to that in 2009?
Ensure brevity in your answer.  0.9. What is the ratio of the Gross enrolment ratio (%) of Armenia in 1999 to that in 2009?
Ensure brevity in your answer.  0.77. What is the ratio of the Gross enrolment ratio (%) of Samoa in 1999 to that in 2009?
Provide a succinct answer. 1.2. What is the ratio of the Gross enrolment ratio (%) in Sao Tome and Principe in 1999 to that in 2009?
Provide a succinct answer. 0.52. What is the ratio of the Gross enrolment ratio (%) in High income in 1999 to that in 2011?
Ensure brevity in your answer.  0.85. What is the ratio of the Gross enrolment ratio (%) in Armenia in 1999 to that in 2011?
Give a very brief answer. 0.55. What is the ratio of the Gross enrolment ratio (%) in Samoa in 1999 to that in 2011?
Provide a short and direct response. 1.27. What is the ratio of the Gross enrolment ratio (%) in Sao Tome and Principe in 1999 to that in 2011?
Give a very brief answer. 0.45. What is the ratio of the Gross enrolment ratio (%) in High income in 1999 to that in 2012?
Give a very brief answer. 0.84. What is the ratio of the Gross enrolment ratio (%) in Armenia in 1999 to that in 2012?
Offer a terse response. 0.52. What is the ratio of the Gross enrolment ratio (%) of Samoa in 1999 to that in 2012?
Keep it short and to the point. 1.46. What is the ratio of the Gross enrolment ratio (%) in Sao Tome and Principe in 1999 to that in 2012?
Give a very brief answer. 0.47. What is the ratio of the Gross enrolment ratio (%) in High income in 2001 to that in 2007?
Ensure brevity in your answer.  0.94. What is the ratio of the Gross enrolment ratio (%) of Armenia in 2001 to that in 2007?
Your answer should be compact. 0.77. What is the ratio of the Gross enrolment ratio (%) of Samoa in 2001 to that in 2007?
Offer a terse response. 1.13. What is the ratio of the Gross enrolment ratio (%) of Sao Tome and Principe in 2001 to that in 2007?
Your answer should be very brief. 0.63. What is the ratio of the Gross enrolment ratio (%) of High income in 2001 to that in 2008?
Make the answer very short. 0.95. What is the ratio of the Gross enrolment ratio (%) in Armenia in 2001 to that in 2008?
Your answer should be compact. 0.75. What is the ratio of the Gross enrolment ratio (%) in Samoa in 2001 to that in 2008?
Offer a very short reply. 1.26. What is the ratio of the Gross enrolment ratio (%) of Sao Tome and Principe in 2001 to that in 2008?
Offer a terse response. 0.62. What is the ratio of the Gross enrolment ratio (%) of High income in 2001 to that in 2009?
Your answer should be compact. 0.94. What is the ratio of the Gross enrolment ratio (%) in Armenia in 2001 to that in 2009?
Offer a terse response. 0.73. What is the ratio of the Gross enrolment ratio (%) in Samoa in 2001 to that in 2009?
Your answer should be very brief. 1.27. What is the ratio of the Gross enrolment ratio (%) in Sao Tome and Principe in 2001 to that in 2009?
Make the answer very short. 0.59. What is the ratio of the Gross enrolment ratio (%) of High income in 2001 to that in 2011?
Provide a succinct answer. 0.89. What is the ratio of the Gross enrolment ratio (%) of Armenia in 2001 to that in 2011?
Ensure brevity in your answer.  0.52. What is the ratio of the Gross enrolment ratio (%) in Samoa in 2001 to that in 2011?
Provide a short and direct response. 1.35. What is the ratio of the Gross enrolment ratio (%) of Sao Tome and Principe in 2001 to that in 2011?
Your answer should be compact. 0.51. What is the ratio of the Gross enrolment ratio (%) in High income in 2001 to that in 2012?
Provide a short and direct response. 0.88. What is the ratio of the Gross enrolment ratio (%) of Armenia in 2001 to that in 2012?
Provide a short and direct response. 0.49. What is the ratio of the Gross enrolment ratio (%) of Samoa in 2001 to that in 2012?
Offer a very short reply. 1.55. What is the ratio of the Gross enrolment ratio (%) in Sao Tome and Principe in 2001 to that in 2012?
Your answer should be compact. 0.53. What is the ratio of the Gross enrolment ratio (%) of Armenia in 2007 to that in 2008?
Provide a succinct answer. 0.98. What is the ratio of the Gross enrolment ratio (%) of Samoa in 2007 to that in 2008?
Give a very brief answer. 1.12. What is the ratio of the Gross enrolment ratio (%) in Sao Tome and Principe in 2007 to that in 2008?
Provide a succinct answer. 0.98. What is the ratio of the Gross enrolment ratio (%) in Armenia in 2007 to that in 2009?
Provide a short and direct response. 0.95. What is the ratio of the Gross enrolment ratio (%) of Samoa in 2007 to that in 2009?
Give a very brief answer. 1.13. What is the ratio of the Gross enrolment ratio (%) of Sao Tome and Principe in 2007 to that in 2009?
Your answer should be very brief. 0.94. What is the ratio of the Gross enrolment ratio (%) of High income in 2007 to that in 2011?
Offer a very short reply. 0.94. What is the ratio of the Gross enrolment ratio (%) in Armenia in 2007 to that in 2011?
Give a very brief answer. 0.68. What is the ratio of the Gross enrolment ratio (%) of Samoa in 2007 to that in 2011?
Your answer should be very brief. 1.2. What is the ratio of the Gross enrolment ratio (%) of Sao Tome and Principe in 2007 to that in 2011?
Make the answer very short. 0.82. What is the ratio of the Gross enrolment ratio (%) of High income in 2007 to that in 2012?
Provide a succinct answer. 0.93. What is the ratio of the Gross enrolment ratio (%) in Armenia in 2007 to that in 2012?
Your answer should be very brief. 0.64. What is the ratio of the Gross enrolment ratio (%) in Samoa in 2007 to that in 2012?
Make the answer very short. 1.38. What is the ratio of the Gross enrolment ratio (%) in Sao Tome and Principe in 2007 to that in 2012?
Your answer should be compact. 0.85. What is the ratio of the Gross enrolment ratio (%) of Armenia in 2008 to that in 2009?
Keep it short and to the point. 0.97. What is the ratio of the Gross enrolment ratio (%) in Samoa in 2008 to that in 2009?
Your answer should be very brief. 1.01. What is the ratio of the Gross enrolment ratio (%) in Sao Tome and Principe in 2008 to that in 2009?
Your response must be concise. 0.95. What is the ratio of the Gross enrolment ratio (%) of High income in 2008 to that in 2011?
Keep it short and to the point. 0.94. What is the ratio of the Gross enrolment ratio (%) of Armenia in 2008 to that in 2011?
Give a very brief answer. 0.69. What is the ratio of the Gross enrolment ratio (%) in Samoa in 2008 to that in 2011?
Provide a succinct answer. 1.07. What is the ratio of the Gross enrolment ratio (%) in Sao Tome and Principe in 2008 to that in 2011?
Offer a very short reply. 0.83. What is the ratio of the Gross enrolment ratio (%) of High income in 2008 to that in 2012?
Your answer should be compact. 0.93. What is the ratio of the Gross enrolment ratio (%) in Armenia in 2008 to that in 2012?
Make the answer very short. 0.65. What is the ratio of the Gross enrolment ratio (%) in Samoa in 2008 to that in 2012?
Offer a terse response. 1.23. What is the ratio of the Gross enrolment ratio (%) in Sao Tome and Principe in 2008 to that in 2012?
Your response must be concise. 0.87. What is the ratio of the Gross enrolment ratio (%) in High income in 2009 to that in 2011?
Make the answer very short. 0.94. What is the ratio of the Gross enrolment ratio (%) in Armenia in 2009 to that in 2011?
Offer a terse response. 0.72. What is the ratio of the Gross enrolment ratio (%) of Samoa in 2009 to that in 2011?
Your answer should be very brief. 1.07. What is the ratio of the Gross enrolment ratio (%) in Sao Tome and Principe in 2009 to that in 2011?
Make the answer very short. 0.87. What is the ratio of the Gross enrolment ratio (%) of High income in 2009 to that in 2012?
Keep it short and to the point. 0.93. What is the ratio of the Gross enrolment ratio (%) of Armenia in 2009 to that in 2012?
Provide a short and direct response. 0.67. What is the ratio of the Gross enrolment ratio (%) of Samoa in 2009 to that in 2012?
Make the answer very short. 1.22. What is the ratio of the Gross enrolment ratio (%) in Sao Tome and Principe in 2009 to that in 2012?
Provide a succinct answer. 0.91. What is the ratio of the Gross enrolment ratio (%) of Armenia in 2011 to that in 2012?
Give a very brief answer. 0.94. What is the ratio of the Gross enrolment ratio (%) of Samoa in 2011 to that in 2012?
Keep it short and to the point. 1.15. What is the ratio of the Gross enrolment ratio (%) in Sao Tome and Principe in 2011 to that in 2012?
Make the answer very short. 1.04. What is the difference between the highest and the second highest Gross enrolment ratio (%) in High income?
Your answer should be very brief. 0.87. What is the difference between the highest and the second highest Gross enrolment ratio (%) in Armenia?
Give a very brief answer. 2.91. What is the difference between the highest and the second highest Gross enrolment ratio (%) of Samoa?
Your answer should be very brief. 3.14. What is the difference between the highest and the second highest Gross enrolment ratio (%) in Sao Tome and Principe?
Ensure brevity in your answer.  2.2. What is the difference between the highest and the lowest Gross enrolment ratio (%) in High income?
Offer a very short reply. 13.63. What is the difference between the highest and the lowest Gross enrolment ratio (%) in Armenia?
Provide a short and direct response. 25.64. What is the difference between the highest and the lowest Gross enrolment ratio (%) in Samoa?
Ensure brevity in your answer.  18.72. What is the difference between the highest and the lowest Gross enrolment ratio (%) of Sao Tome and Principe?
Ensure brevity in your answer.  28.68. 